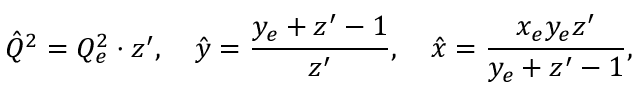<formula> <loc_0><loc_0><loc_500><loc_500>\hat { Q } ^ { 2 } = Q _ { e } ^ { 2 } \cdot z ^ { \prime } , \quad \hat { y } = \frac { y _ { e } + z ^ { \prime } - 1 } { z ^ { \prime } } , \quad \hat { x } = \frac { x _ { e } y _ { e } z ^ { \prime } } { y _ { e } + z ^ { \prime } - 1 } ,</formula> 